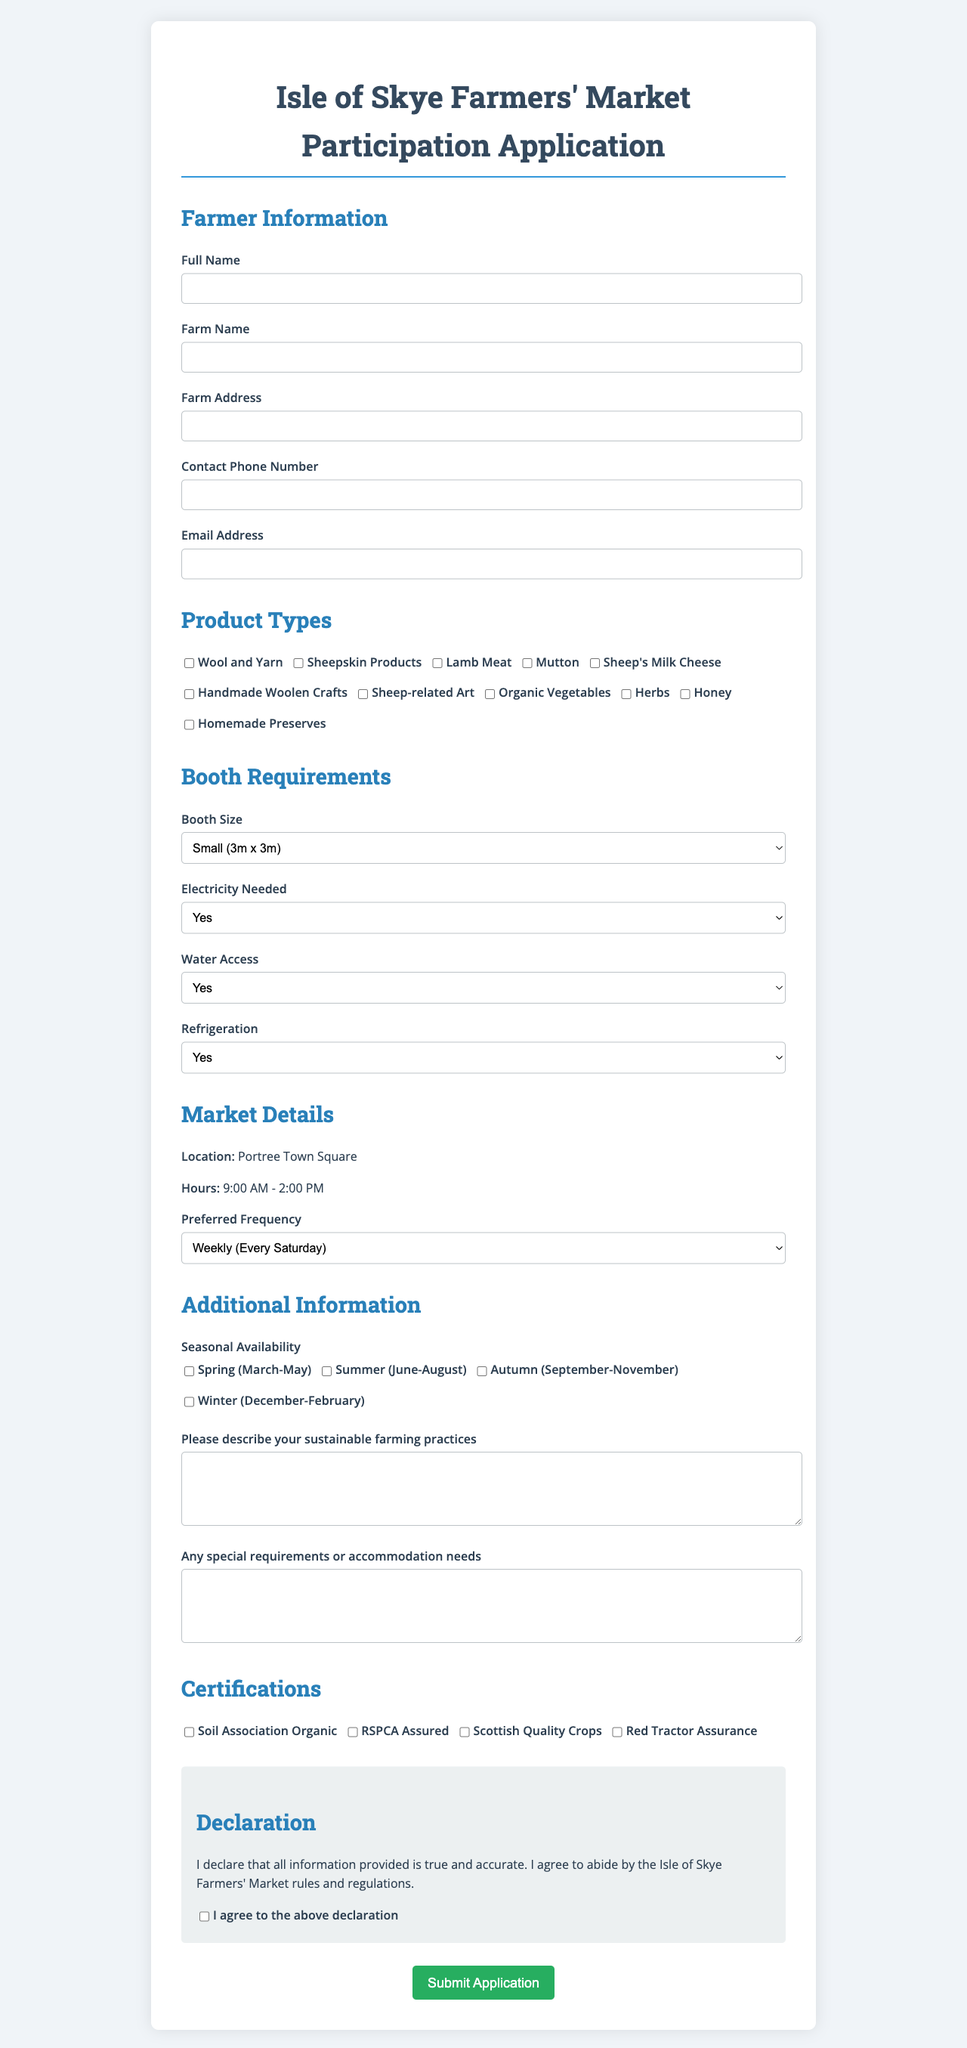What is the form title? The form title is prominently displayed at the top of the document.
Answer: Isle of Skye Farmers' Market Participation Application What are the available product types? The available product types are listed under the "Product Types" section.
Answer: Wool and Yarn, Sheepskin Products, Lamb Meat, Mutton, Sheep's Milk Cheese, Handmade Woolen Crafts, Sheep-related Art, Organic Vegetables, Herbs, Honey, Homemade Preserves Where is the market located? The location of the market is mentioned in the "Market Details" section.
Answer: Portree Town Square What is the preferred frequency of the market? The preferred frequency options are provided in a dropdown menu under "Market Details."
Answer: Weekly (Every Saturday), Bi-weekly (Every other Saturday), Monthly (First Saturday of the month) What is the booth size mentioned? Various booth size options are listed in the "Booth Requirements" section.
Answer: Small (3m x 3m), Medium (4.5m x 3m), Large (6m x 3m) Is electricity needed required? The electricity requirement is indicated in the "Booth Requirements" section.
Answer: Yes/No What is the sustainability practices section about? This section asks for a description of the applicant’s sustainable farming practices.
Answer: Please describe your sustainable farming practices How often does the market occur? The frequency options outline how often the market is held.
Answer: Weekly (Every Saturday), Bi-weekly (Every other Saturday), Monthly (First Saturday of the month) What is the declaration statement? The declaration is a statement that reflects the agreement and truthfulness of the information provided.
Answer: I declare that all information provided is true and accurate. I agree to abide by the Isle of Skye Farmers' Market rules and regulations 